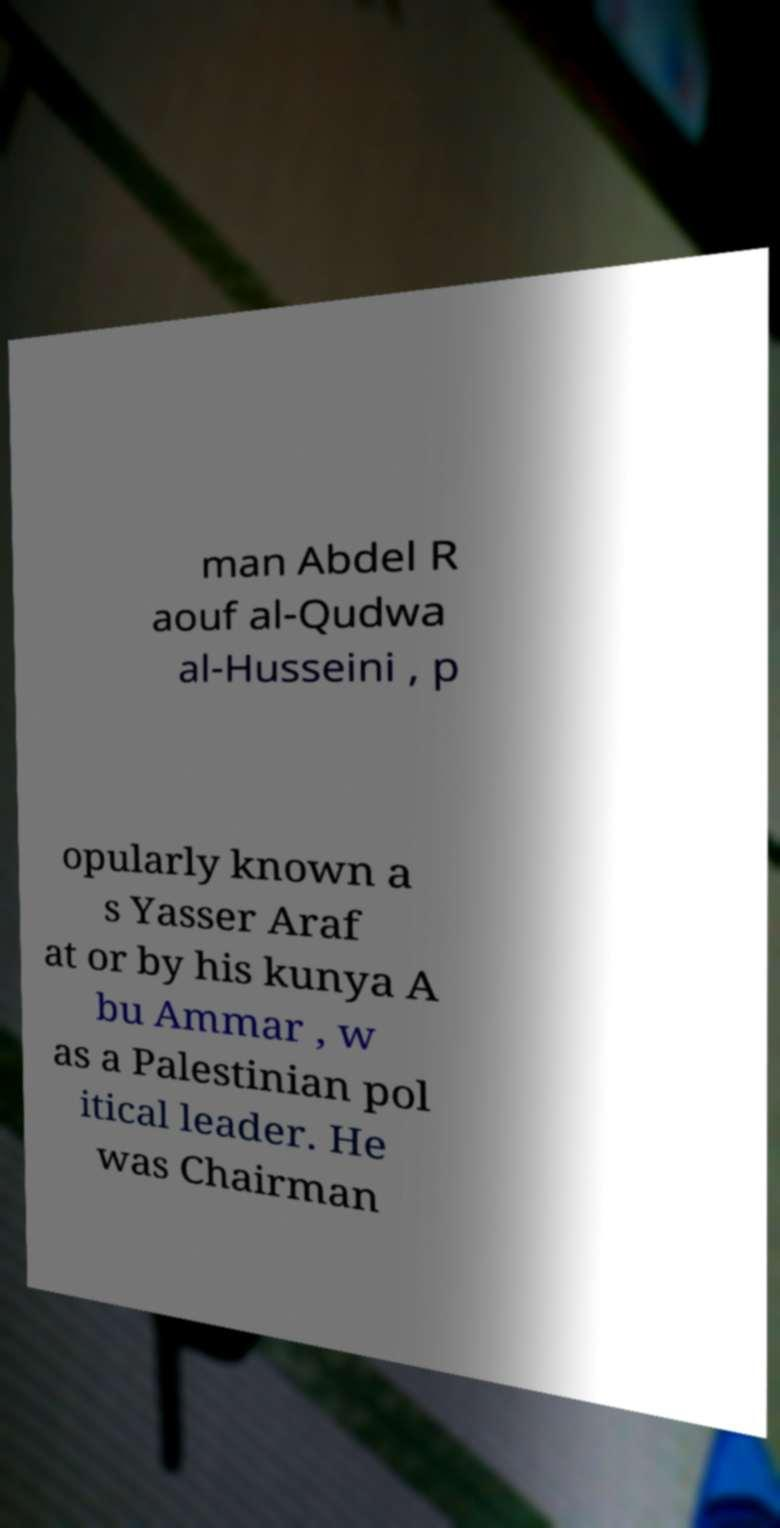There's text embedded in this image that I need extracted. Can you transcribe it verbatim? man Abdel R aouf al-Qudwa al-Husseini , p opularly known a s Yasser Araf at or by his kunya A bu Ammar , w as a Palestinian pol itical leader. He was Chairman 